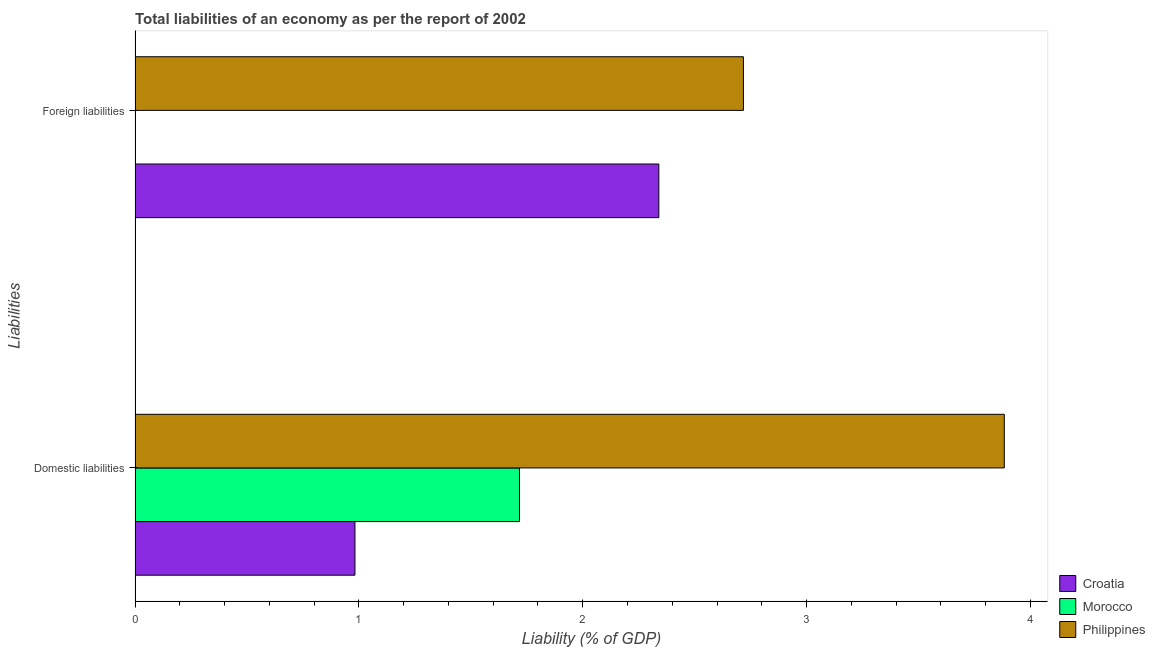How many groups of bars are there?
Make the answer very short. 2. Are the number of bars per tick equal to the number of legend labels?
Your answer should be very brief. No. Are the number of bars on each tick of the Y-axis equal?
Ensure brevity in your answer.  No. What is the label of the 1st group of bars from the top?
Provide a succinct answer. Foreign liabilities. What is the incurrence of domestic liabilities in Philippines?
Give a very brief answer. 3.88. Across all countries, what is the maximum incurrence of foreign liabilities?
Provide a short and direct response. 2.72. In which country was the incurrence of domestic liabilities maximum?
Keep it short and to the point. Philippines. What is the total incurrence of domestic liabilities in the graph?
Provide a succinct answer. 6.58. What is the difference between the incurrence of domestic liabilities in Philippines and that in Croatia?
Offer a terse response. 2.9. What is the difference between the incurrence of foreign liabilities in Croatia and the incurrence of domestic liabilities in Philippines?
Provide a short and direct response. -1.54. What is the average incurrence of foreign liabilities per country?
Your answer should be compact. 1.69. What is the difference between the incurrence of foreign liabilities and incurrence of domestic liabilities in Philippines?
Offer a very short reply. -1.17. In how many countries, is the incurrence of domestic liabilities greater than 3 %?
Make the answer very short. 1. What is the ratio of the incurrence of domestic liabilities in Philippines to that in Croatia?
Provide a succinct answer. 3.95. How many bars are there?
Offer a very short reply. 5. Are all the bars in the graph horizontal?
Offer a terse response. Yes. What is the difference between two consecutive major ticks on the X-axis?
Provide a short and direct response. 1. Does the graph contain any zero values?
Give a very brief answer. Yes. Where does the legend appear in the graph?
Keep it short and to the point. Bottom right. How many legend labels are there?
Give a very brief answer. 3. How are the legend labels stacked?
Provide a succinct answer. Vertical. What is the title of the graph?
Provide a short and direct response. Total liabilities of an economy as per the report of 2002. What is the label or title of the X-axis?
Offer a terse response. Liability (% of GDP). What is the label or title of the Y-axis?
Offer a very short reply. Liabilities. What is the Liability (% of GDP) in Croatia in Domestic liabilities?
Your answer should be compact. 0.98. What is the Liability (% of GDP) of Morocco in Domestic liabilities?
Provide a short and direct response. 1.72. What is the Liability (% of GDP) in Philippines in Domestic liabilities?
Ensure brevity in your answer.  3.88. What is the Liability (% of GDP) of Croatia in Foreign liabilities?
Provide a short and direct response. 2.34. What is the Liability (% of GDP) of Morocco in Foreign liabilities?
Ensure brevity in your answer.  0. What is the Liability (% of GDP) in Philippines in Foreign liabilities?
Give a very brief answer. 2.72. Across all Liabilities, what is the maximum Liability (% of GDP) in Croatia?
Provide a succinct answer. 2.34. Across all Liabilities, what is the maximum Liability (% of GDP) in Morocco?
Ensure brevity in your answer.  1.72. Across all Liabilities, what is the maximum Liability (% of GDP) in Philippines?
Offer a very short reply. 3.88. Across all Liabilities, what is the minimum Liability (% of GDP) of Croatia?
Provide a short and direct response. 0.98. Across all Liabilities, what is the minimum Liability (% of GDP) in Morocco?
Provide a succinct answer. 0. Across all Liabilities, what is the minimum Liability (% of GDP) of Philippines?
Your answer should be very brief. 2.72. What is the total Liability (% of GDP) of Croatia in the graph?
Provide a short and direct response. 3.32. What is the total Liability (% of GDP) of Morocco in the graph?
Offer a terse response. 1.72. What is the total Liability (% of GDP) of Philippines in the graph?
Keep it short and to the point. 6.6. What is the difference between the Liability (% of GDP) in Croatia in Domestic liabilities and that in Foreign liabilities?
Provide a short and direct response. -1.36. What is the difference between the Liability (% of GDP) in Philippines in Domestic liabilities and that in Foreign liabilities?
Give a very brief answer. 1.17. What is the difference between the Liability (% of GDP) of Croatia in Domestic liabilities and the Liability (% of GDP) of Philippines in Foreign liabilities?
Provide a short and direct response. -1.74. What is the difference between the Liability (% of GDP) of Morocco in Domestic liabilities and the Liability (% of GDP) of Philippines in Foreign liabilities?
Offer a very short reply. -1. What is the average Liability (% of GDP) in Croatia per Liabilities?
Offer a very short reply. 1.66. What is the average Liability (% of GDP) in Morocco per Liabilities?
Give a very brief answer. 0.86. What is the average Liability (% of GDP) in Philippines per Liabilities?
Your response must be concise. 3.3. What is the difference between the Liability (% of GDP) of Croatia and Liability (% of GDP) of Morocco in Domestic liabilities?
Give a very brief answer. -0.74. What is the difference between the Liability (% of GDP) of Croatia and Liability (% of GDP) of Philippines in Domestic liabilities?
Provide a succinct answer. -2.9. What is the difference between the Liability (% of GDP) of Morocco and Liability (% of GDP) of Philippines in Domestic liabilities?
Your answer should be very brief. -2.17. What is the difference between the Liability (% of GDP) in Croatia and Liability (% of GDP) in Philippines in Foreign liabilities?
Ensure brevity in your answer.  -0.38. What is the ratio of the Liability (% of GDP) in Croatia in Domestic liabilities to that in Foreign liabilities?
Offer a very short reply. 0.42. What is the ratio of the Liability (% of GDP) of Philippines in Domestic liabilities to that in Foreign liabilities?
Your response must be concise. 1.43. What is the difference between the highest and the second highest Liability (% of GDP) in Croatia?
Provide a succinct answer. 1.36. What is the difference between the highest and the second highest Liability (% of GDP) in Philippines?
Your response must be concise. 1.17. What is the difference between the highest and the lowest Liability (% of GDP) in Croatia?
Ensure brevity in your answer.  1.36. What is the difference between the highest and the lowest Liability (% of GDP) of Morocco?
Provide a short and direct response. 1.72. What is the difference between the highest and the lowest Liability (% of GDP) of Philippines?
Keep it short and to the point. 1.17. 